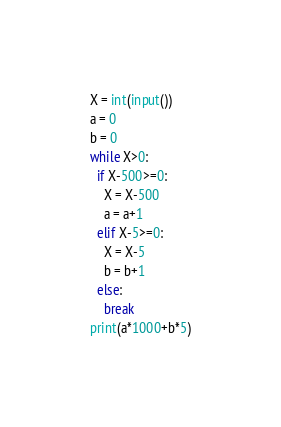Convert code to text. <code><loc_0><loc_0><loc_500><loc_500><_Python_>X = int(input())
a = 0
b = 0
while X>0:
  if X-500>=0:
    X = X-500
    a = a+1
  elif X-5>=0:
    X = X-5
    b = b+1
  else:
    break
print(a*1000+b*5)</code> 